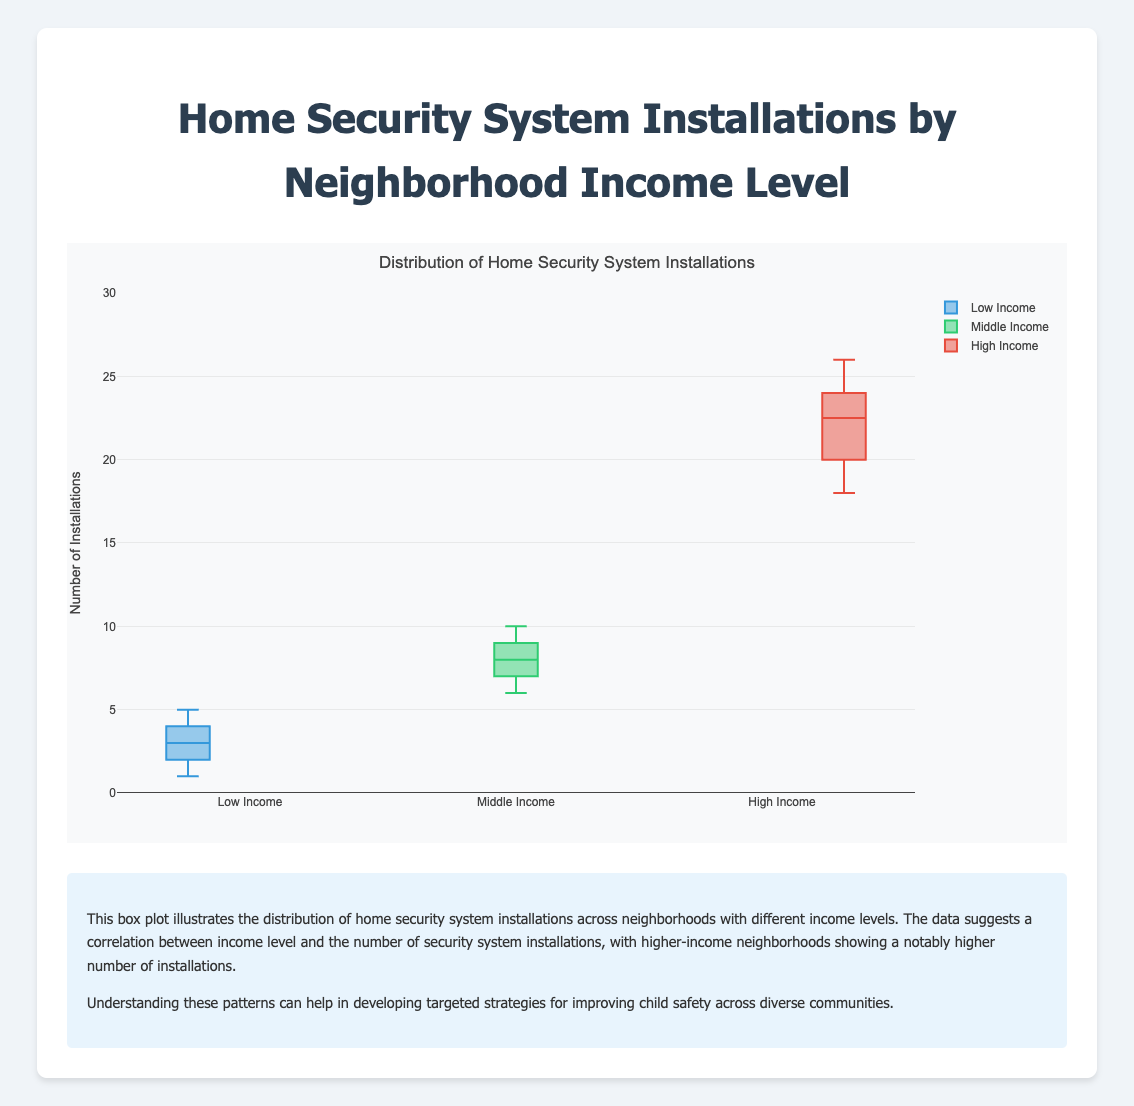What is the title of the plot? The title is displayed at the top of the plot, serving as the main heading.
Answer: Home Security System Installations by Neighborhood Income Level How many income levels are compared in this plot? The plot categorizes data by income, indicated by the three distinct box plots labeled on the x-axis.
Answer: 3 Which income level shows the highest median number of installations? Look for the line inside the box of each income level; the topmost line represents the highest median.
Answer: High Income What is the median value of installations for the 'Middle Income' neighborhoods? The median for the Middle Income group is the line inside the box plot, found around the middle of the green box.
Answer: 8 How does the range of installations for 'Low Income' neighborhoods compare to 'High Income' neighborhoods? Compare the vertical span of the boxes; Low Income spans from 1 to 5 and High Income from 18 to 26.
Answer: High Income's range is larger What is the interquartile range (IQR) for the 'Low Income' group? The IQR is the difference between the third quartile (upper edge of the box) and the first quartile (lower edge of the box). For Low Income, it is 4-2.
Answer: 2 Which income level has the largest variation in installations? The level with the tallest box plot has the largest variation; High Income's box is the tallest.
Answer: High Income Are there any outliers in the installations for 'Middle Income' neighborhoods? Outliers typically appear as dots outside the whiskers; the Middle Income plot does not show such dots.
Answer: No What is the maximum number of installations observed in the 'High Income' group? The top whisker or the highest point in the box plot marks the maximum value.
Answer: 26 Which neighborhood has a higher median installation number, 'Park Slope' or 'Silver Lake'? Both 'Park Slope' and 'Silver Lake' fall under 'Middle Income', so check their similar medians in the same box plot.
Answer: Tie (both are 8) 